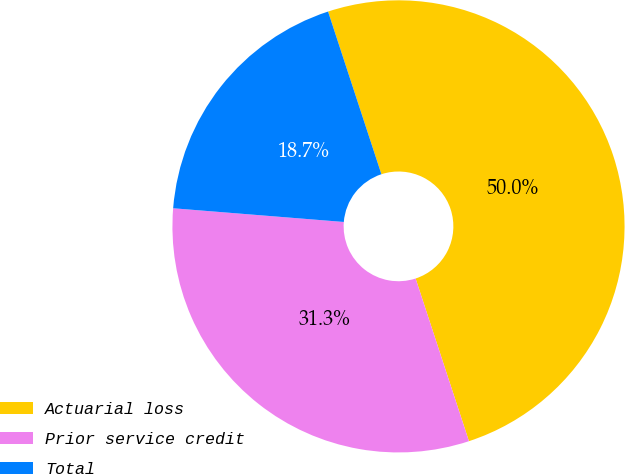<chart> <loc_0><loc_0><loc_500><loc_500><pie_chart><fcel>Actuarial loss<fcel>Prior service credit<fcel>Total<nl><fcel>50.0%<fcel>31.32%<fcel>18.68%<nl></chart> 